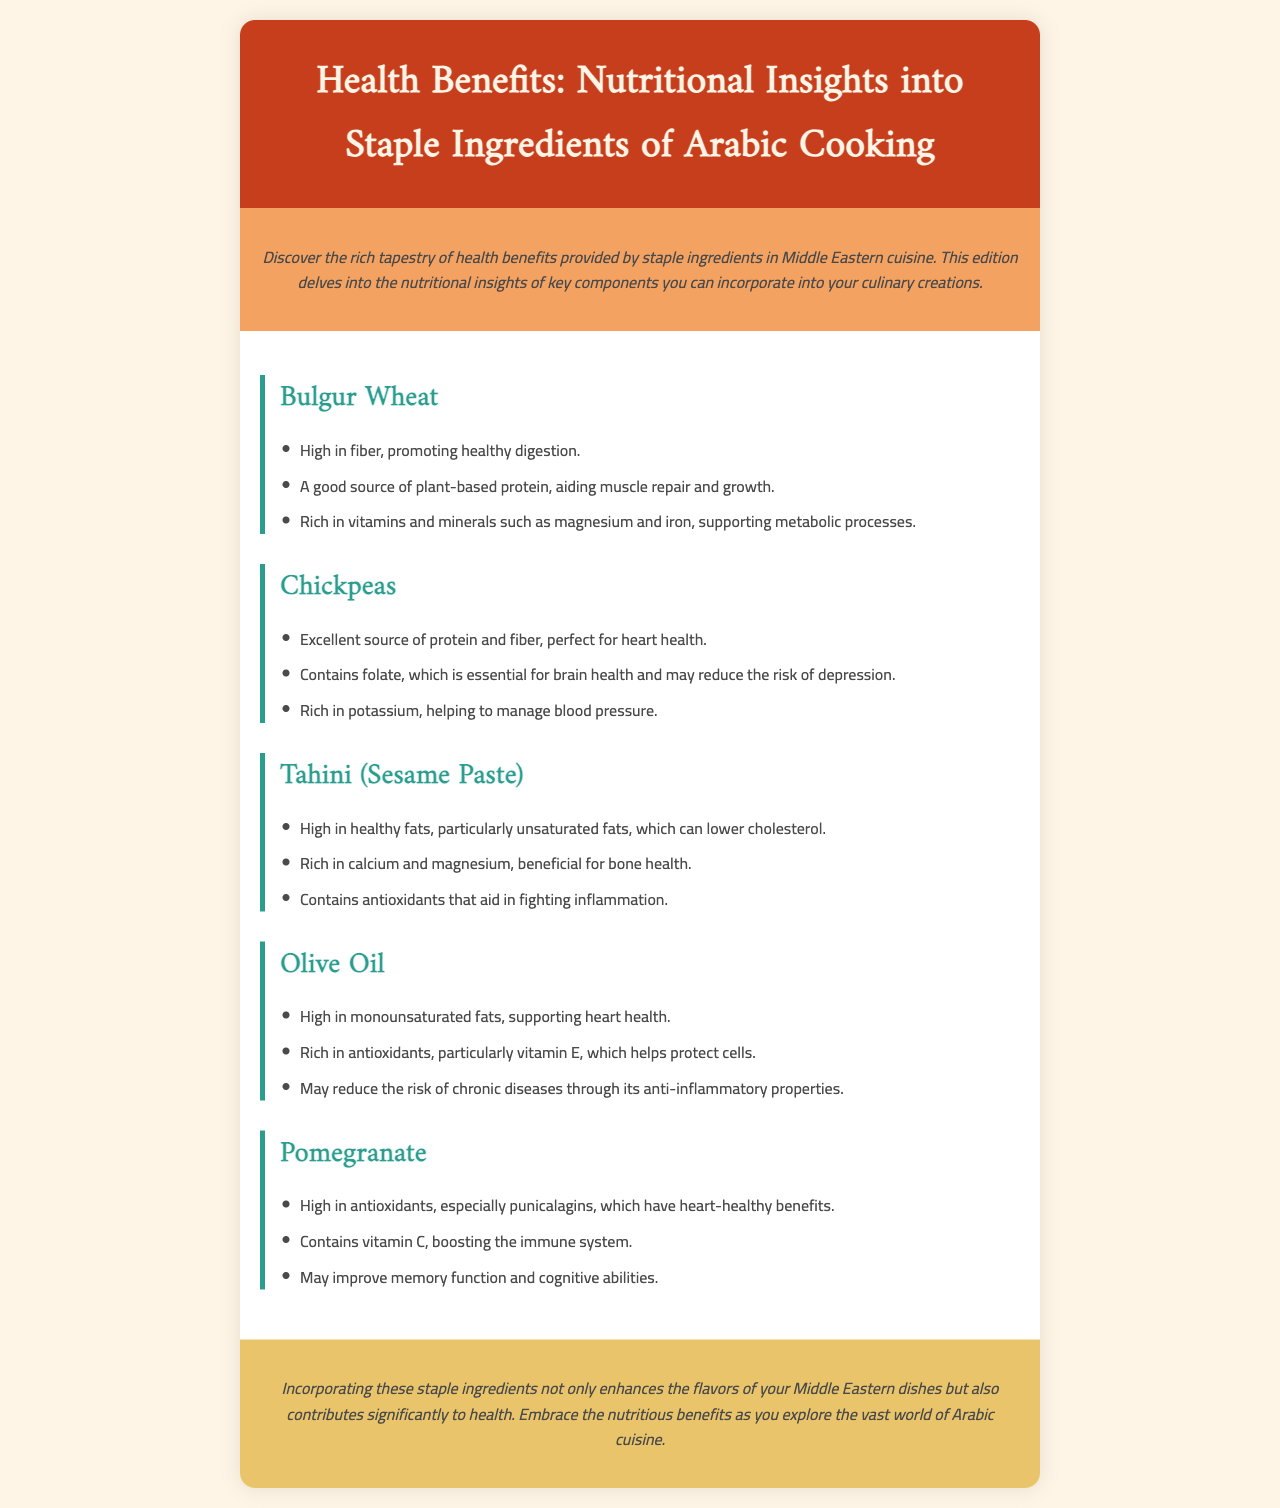What is the main topic of the newsletter? The topic of the newsletter is centered on the health benefits and nutritional insights of staple ingredients used in Arabic cooking.
Answer: Health Benefits: Nutritional Insights into Staple Ingredients of Arabic Cooking How many staple ingredients are discussed in the document? The document discusses a total of five staple ingredients commonly used in Middle Eastern cuisine.
Answer: Five What are the health benefits of Bulgur Wheat? The health benefits listed include high fiber content, a good source of plant-based protein, and richness in vitamins and minerals such as magnesium and iron.
Answer: High in fiber, protein, vitamins, and minerals What is a key benefit of Chickpeas mentioned in the newsletter? A specific key benefit of Chickpeas mentioned is that they are an excellent source of protein and fiber, which is good for heart health.
Answer: Excellent source of protein and fiber Which ingredient is rich in calcium and magnesium? The ingredient mentioned in the document that is rich in calcium and magnesium is Tahini (Sesame Paste).
Answer: Tahini (Sesame Paste) What is one of the benefits of Olive Oil? One benefit of Olive Oil is that it is high in monounsaturated fats, which support heart health.
Answer: High in monounsaturated fats What nutrient is Pomegranate particularly high in? Pomegranate is particularly high in antioxidants, especially punicalagins.
Answer: Antioxidants Which ingredient is associated with potential cognitive benefits? Pomegranate is the ingredient associated with potential cognitive benefits, including improved memory function.
Answer: Pomegranate 